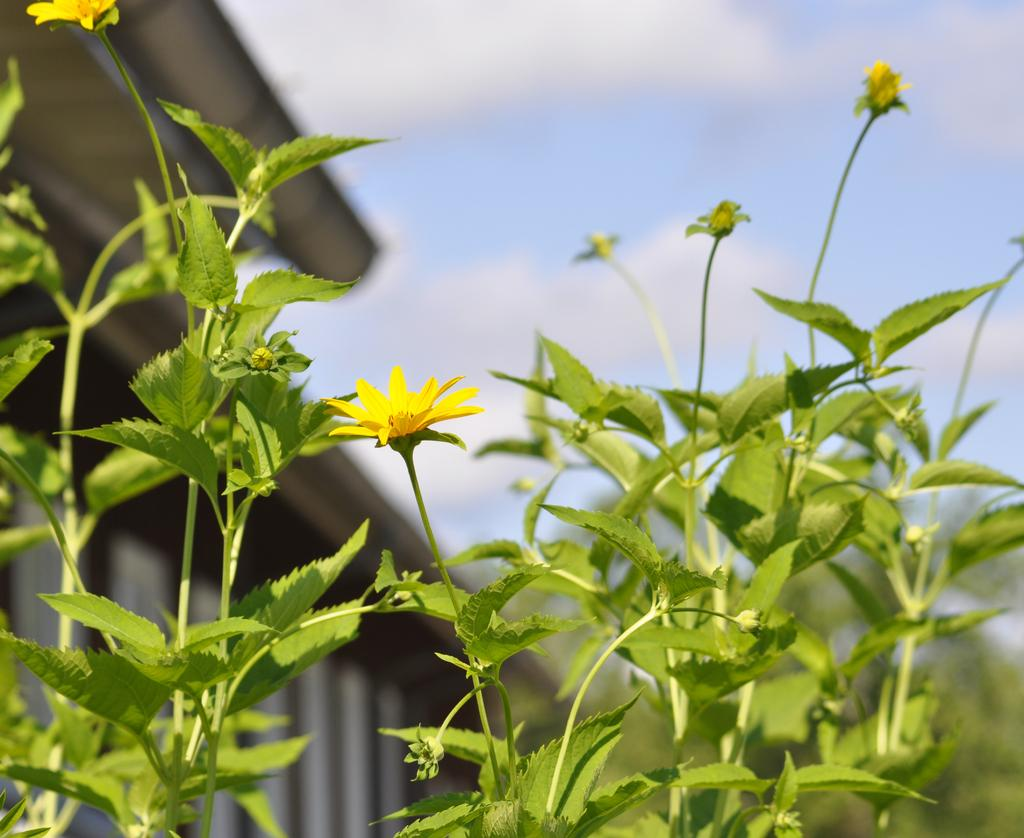What type of living organisms can be seen in the image? Plants and flowers are visible in the image. What part of the natural environment is visible in the image? The sky is visible at the top of the image. What rule is being enforced by the airplane in the image? There is no airplane present in the image, so no rule enforcement can be observed. What type of boundary can be seen between the plants and flowers in the image? There is no boundary visible between the plants and flowers in the image; they are intermingled. 